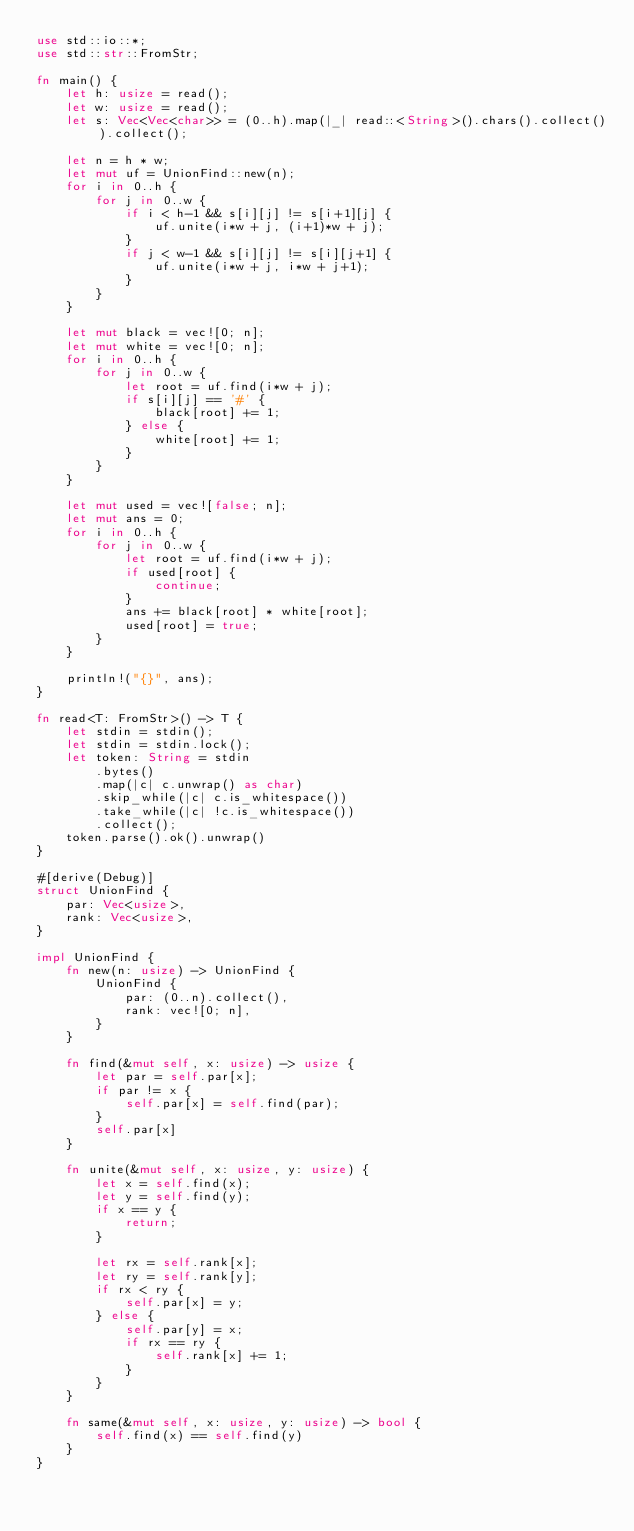Convert code to text. <code><loc_0><loc_0><loc_500><loc_500><_Rust_>use std::io::*;
use std::str::FromStr;

fn main() {
    let h: usize = read();
    let w: usize = read();
    let s: Vec<Vec<char>> = (0..h).map(|_| read::<String>().chars().collect()).collect();

    let n = h * w;
    let mut uf = UnionFind::new(n);
    for i in 0..h {
        for j in 0..w {
            if i < h-1 && s[i][j] != s[i+1][j] {
                uf.unite(i*w + j, (i+1)*w + j);
            }
            if j < w-1 && s[i][j] != s[i][j+1] {
                uf.unite(i*w + j, i*w + j+1);
            }
        }
    }

    let mut black = vec![0; n];
    let mut white = vec![0; n];
    for i in 0..h {
        for j in 0..w {
            let root = uf.find(i*w + j);
            if s[i][j] == '#' {
                black[root] += 1;
            } else {
                white[root] += 1;
            }
        }
    }

    let mut used = vec![false; n];
    let mut ans = 0;
    for i in 0..h {
        for j in 0..w {
            let root = uf.find(i*w + j);
            if used[root] {
                continue;
            }
            ans += black[root] * white[root];
            used[root] = true;
        }
    }

    println!("{}", ans);
}

fn read<T: FromStr>() -> T {
    let stdin = stdin();
    let stdin = stdin.lock();
    let token: String = stdin
        .bytes()
        .map(|c| c.unwrap() as char)
        .skip_while(|c| c.is_whitespace())
        .take_while(|c| !c.is_whitespace())
        .collect();
    token.parse().ok().unwrap()
}

#[derive(Debug)]
struct UnionFind {
    par: Vec<usize>,
    rank: Vec<usize>,
}

impl UnionFind {
    fn new(n: usize) -> UnionFind {
        UnionFind {
            par: (0..n).collect(),
            rank: vec![0; n],
        }
    }

    fn find(&mut self, x: usize) -> usize {
        let par = self.par[x];
        if par != x {
            self.par[x] = self.find(par);
        }
        self.par[x]
    }

    fn unite(&mut self, x: usize, y: usize) {
        let x = self.find(x);
        let y = self.find(y);
        if x == y {
            return;
        }

        let rx = self.rank[x];
        let ry = self.rank[y];
        if rx < ry {
            self.par[x] = y;
        } else {
            self.par[y] = x;
            if rx == ry {
                self.rank[x] += 1;
            }
        }
    }

    fn same(&mut self, x: usize, y: usize) -> bool {
        self.find(x) == self.find(y)
    }
}</code> 